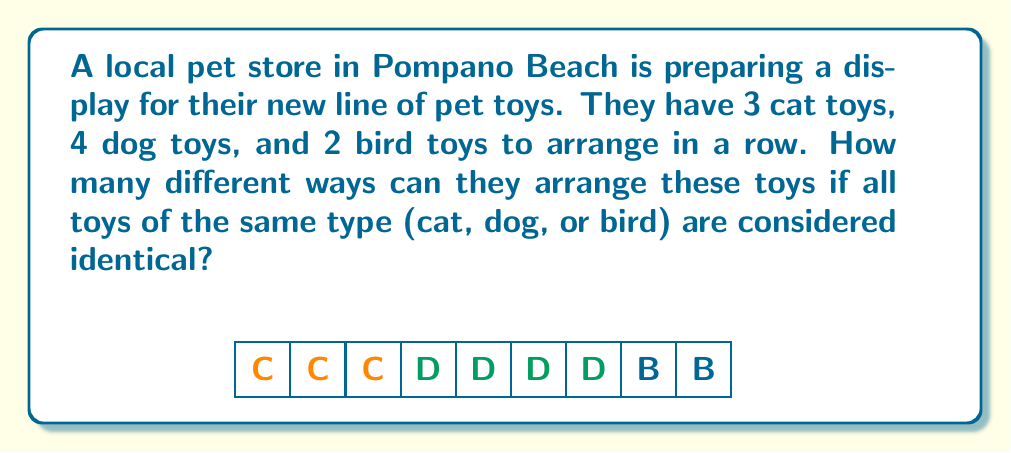Can you solve this math problem? Let's approach this step-by-step:

1) First, we need to recognize that this is a permutation with repetition problem. We are arranging 9 items in total, but some are identical.

2) The formula for permutations with repetition is:

   $$\frac{n!}{n_1!n_2!...n_k!}$$

   Where $n$ is the total number of items, and $n_1, n_2, ..., n_k$ are the numbers of each type of item.

3) In this case:
   - Total number of items: $n = 3 + 4 + 2 = 9$
   - Number of cat toys: $n_1 = 3$
   - Number of dog toys: $n_2 = 4$
   - Number of bird toys: $n_3 = 2$

4) Plugging these into our formula:

   $$\frac{9!}{3!4!2!}$$

5) Let's calculate this:
   
   $$\frac{9 * 8 * 7 * 6 * 5 * 4!}{3 * 2 * 1 * 4! * 2 * 1}$$

6) The 4! cancels out in the numerator and denominator:

   $$\frac{9 * 8 * 7 * 6 * 5}{3 * 2 * 1 * 2 * 1}$$

7) Multiply the numerator and denominator:

   $$\frac{15120}{12}$$

8) Divide:

   $$1260$$

Therefore, there are 1260 different ways to arrange the toys.
Answer: 1260 